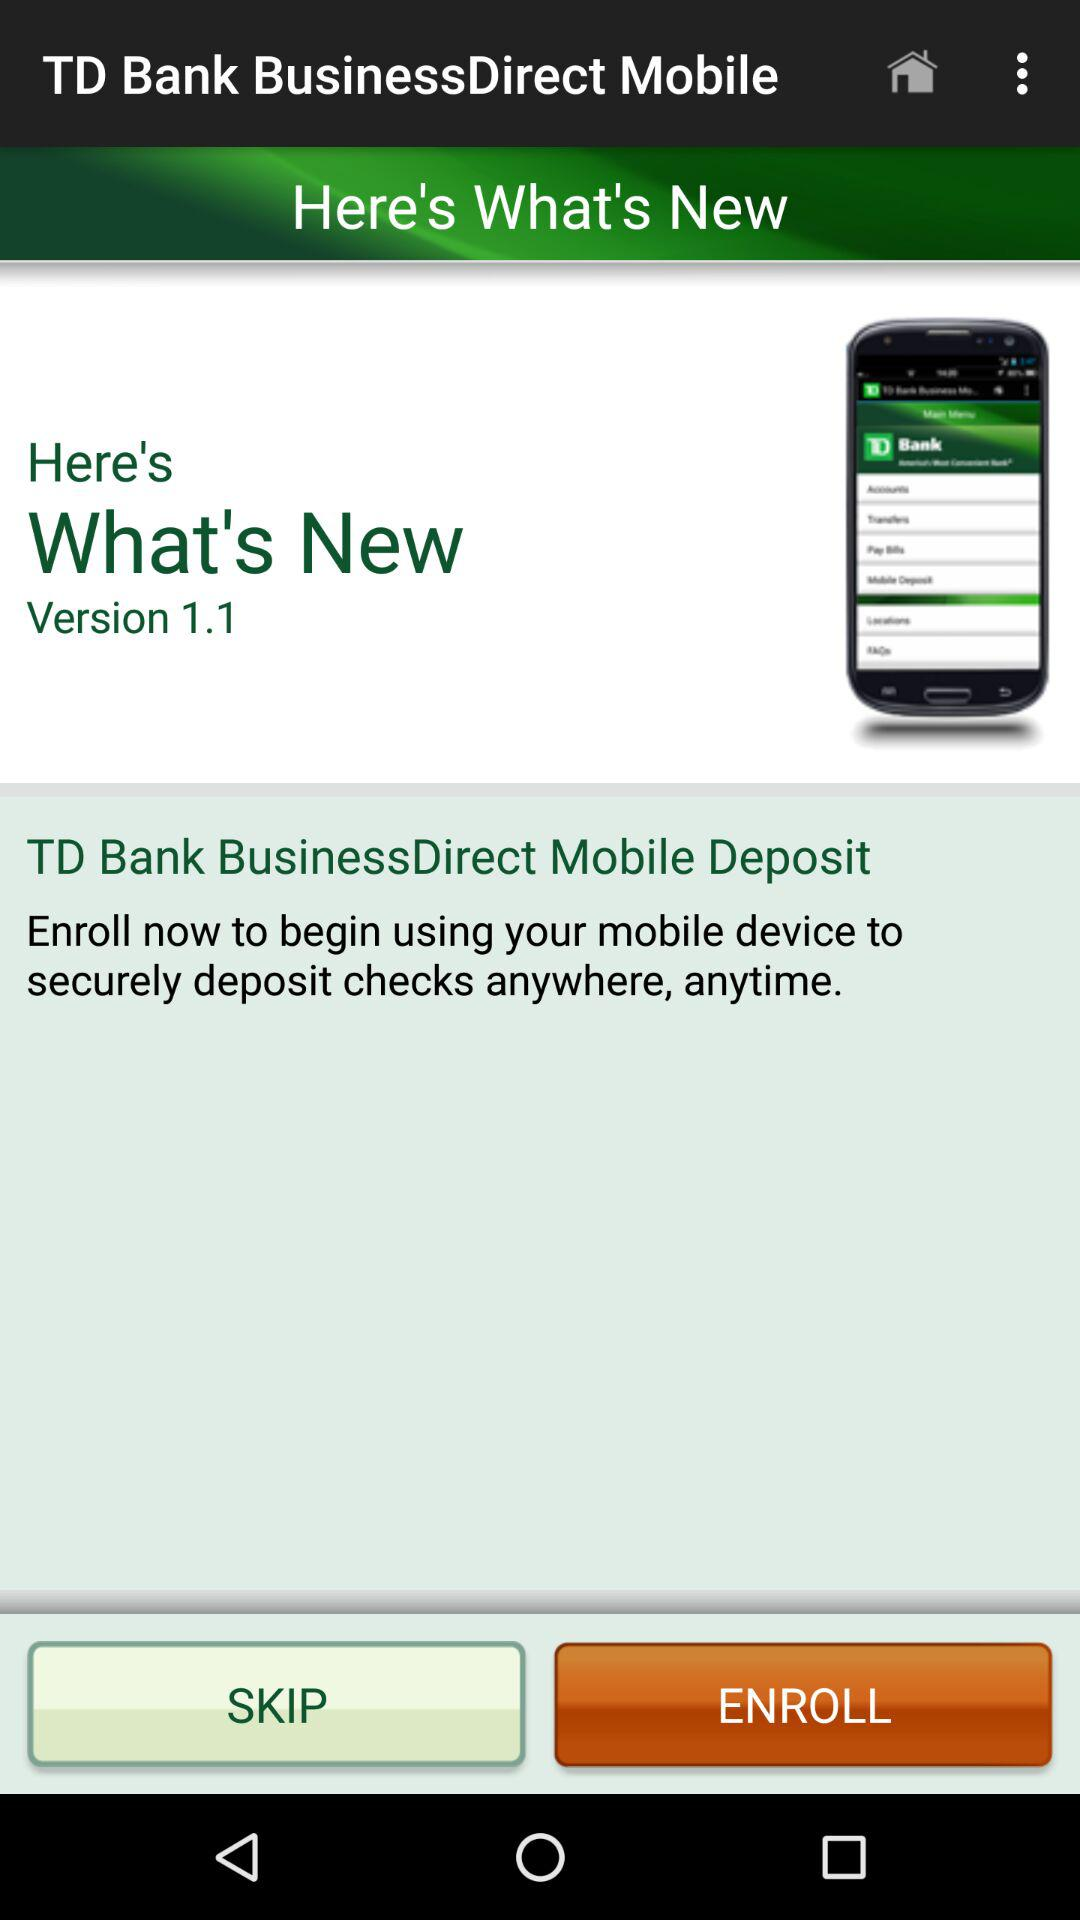What are the new features in Version 1.1?
When the provided information is insufficient, respond with <no answer>. <no answer> 